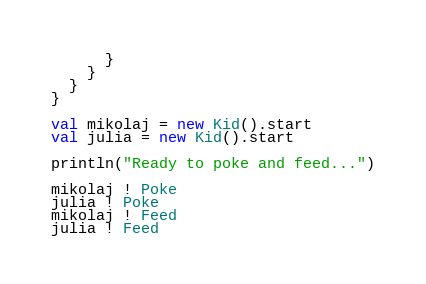<code> <loc_0><loc_0><loc_500><loc_500><_Scala_>      }
    }
  }
}

val mikolaj = new Kid().start
val julia = new Kid().start

println("Ready to poke and feed...")

mikolaj ! Poke
julia ! Poke
mikolaj ! Feed
julia ! Feed
</code> 